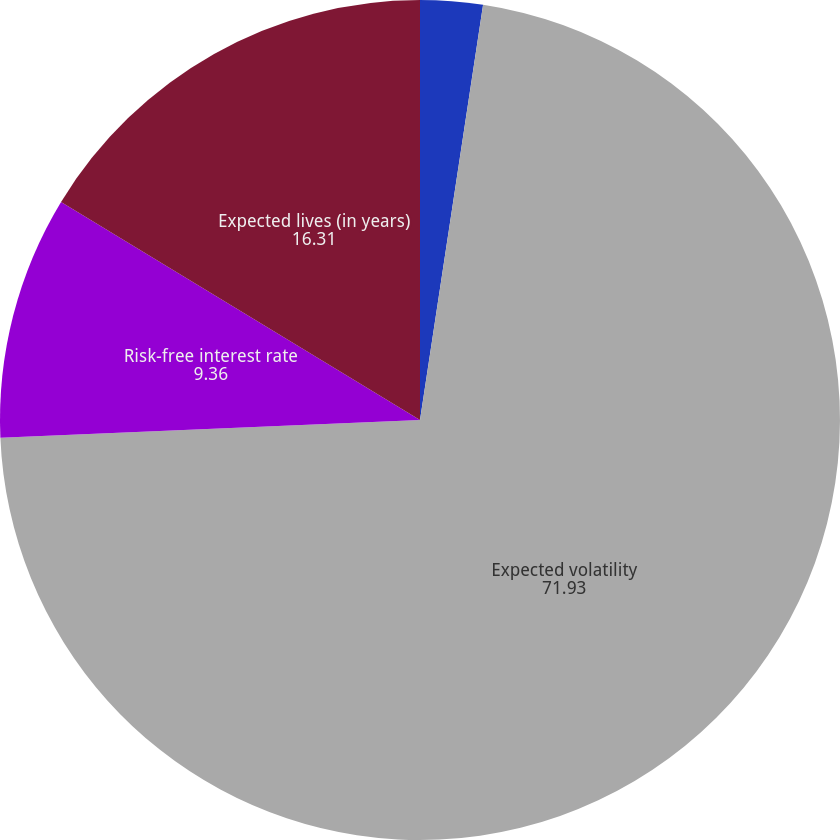<chart> <loc_0><loc_0><loc_500><loc_500><pie_chart><fcel>Dividend yield<fcel>Expected volatility<fcel>Risk-free interest rate<fcel>Expected lives (in years)<nl><fcel>2.4%<fcel>71.93%<fcel>9.36%<fcel>16.31%<nl></chart> 